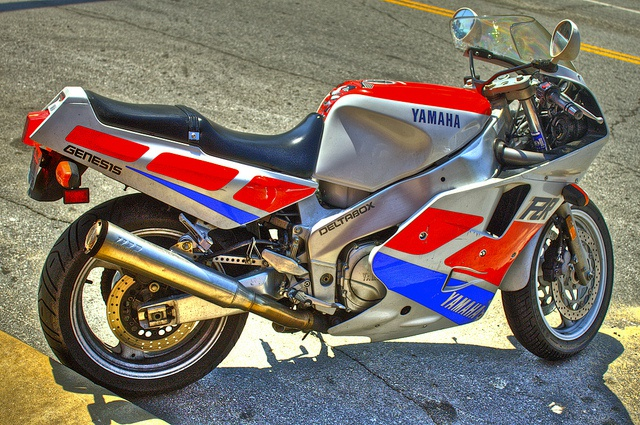Describe the objects in this image and their specific colors. I can see a motorcycle in darkgray, black, gray, and red tones in this image. 